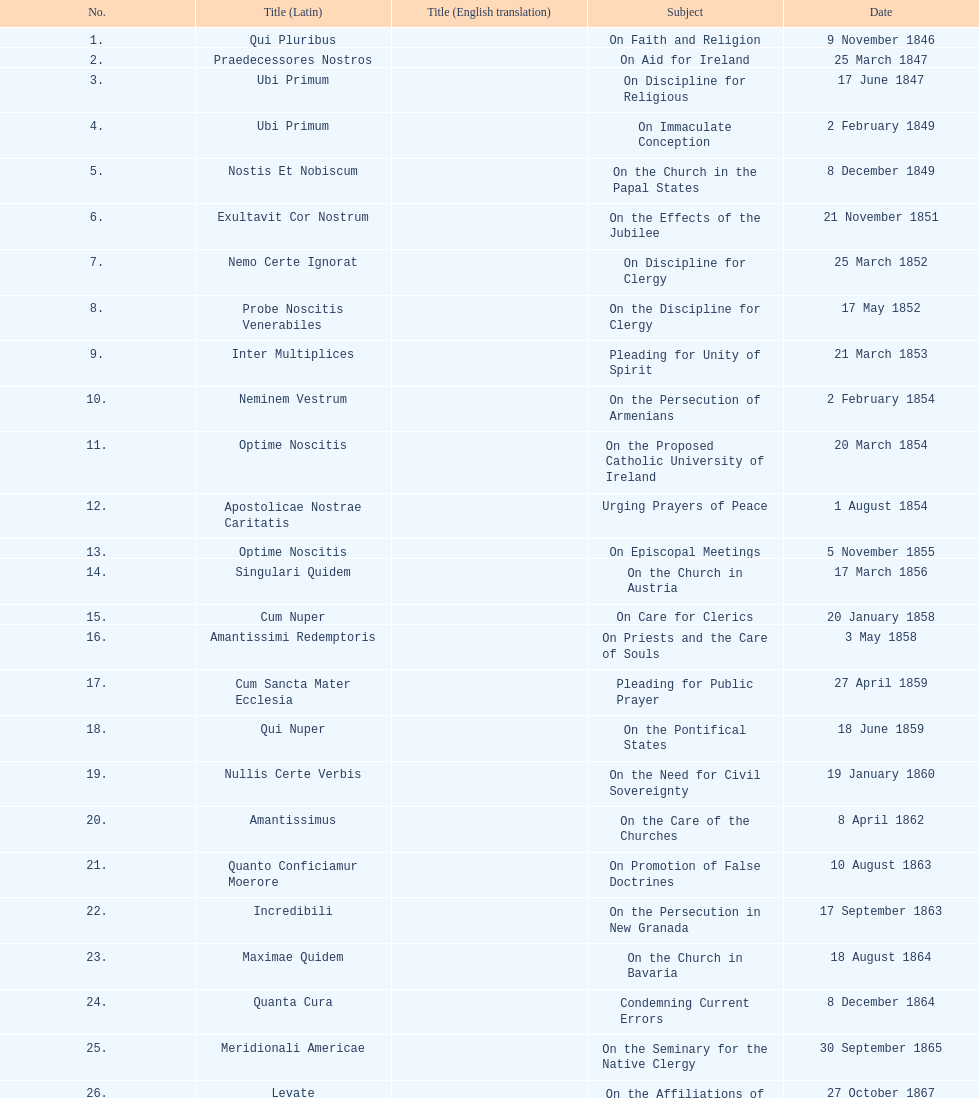How often was an encyclical sent in january? 3. 